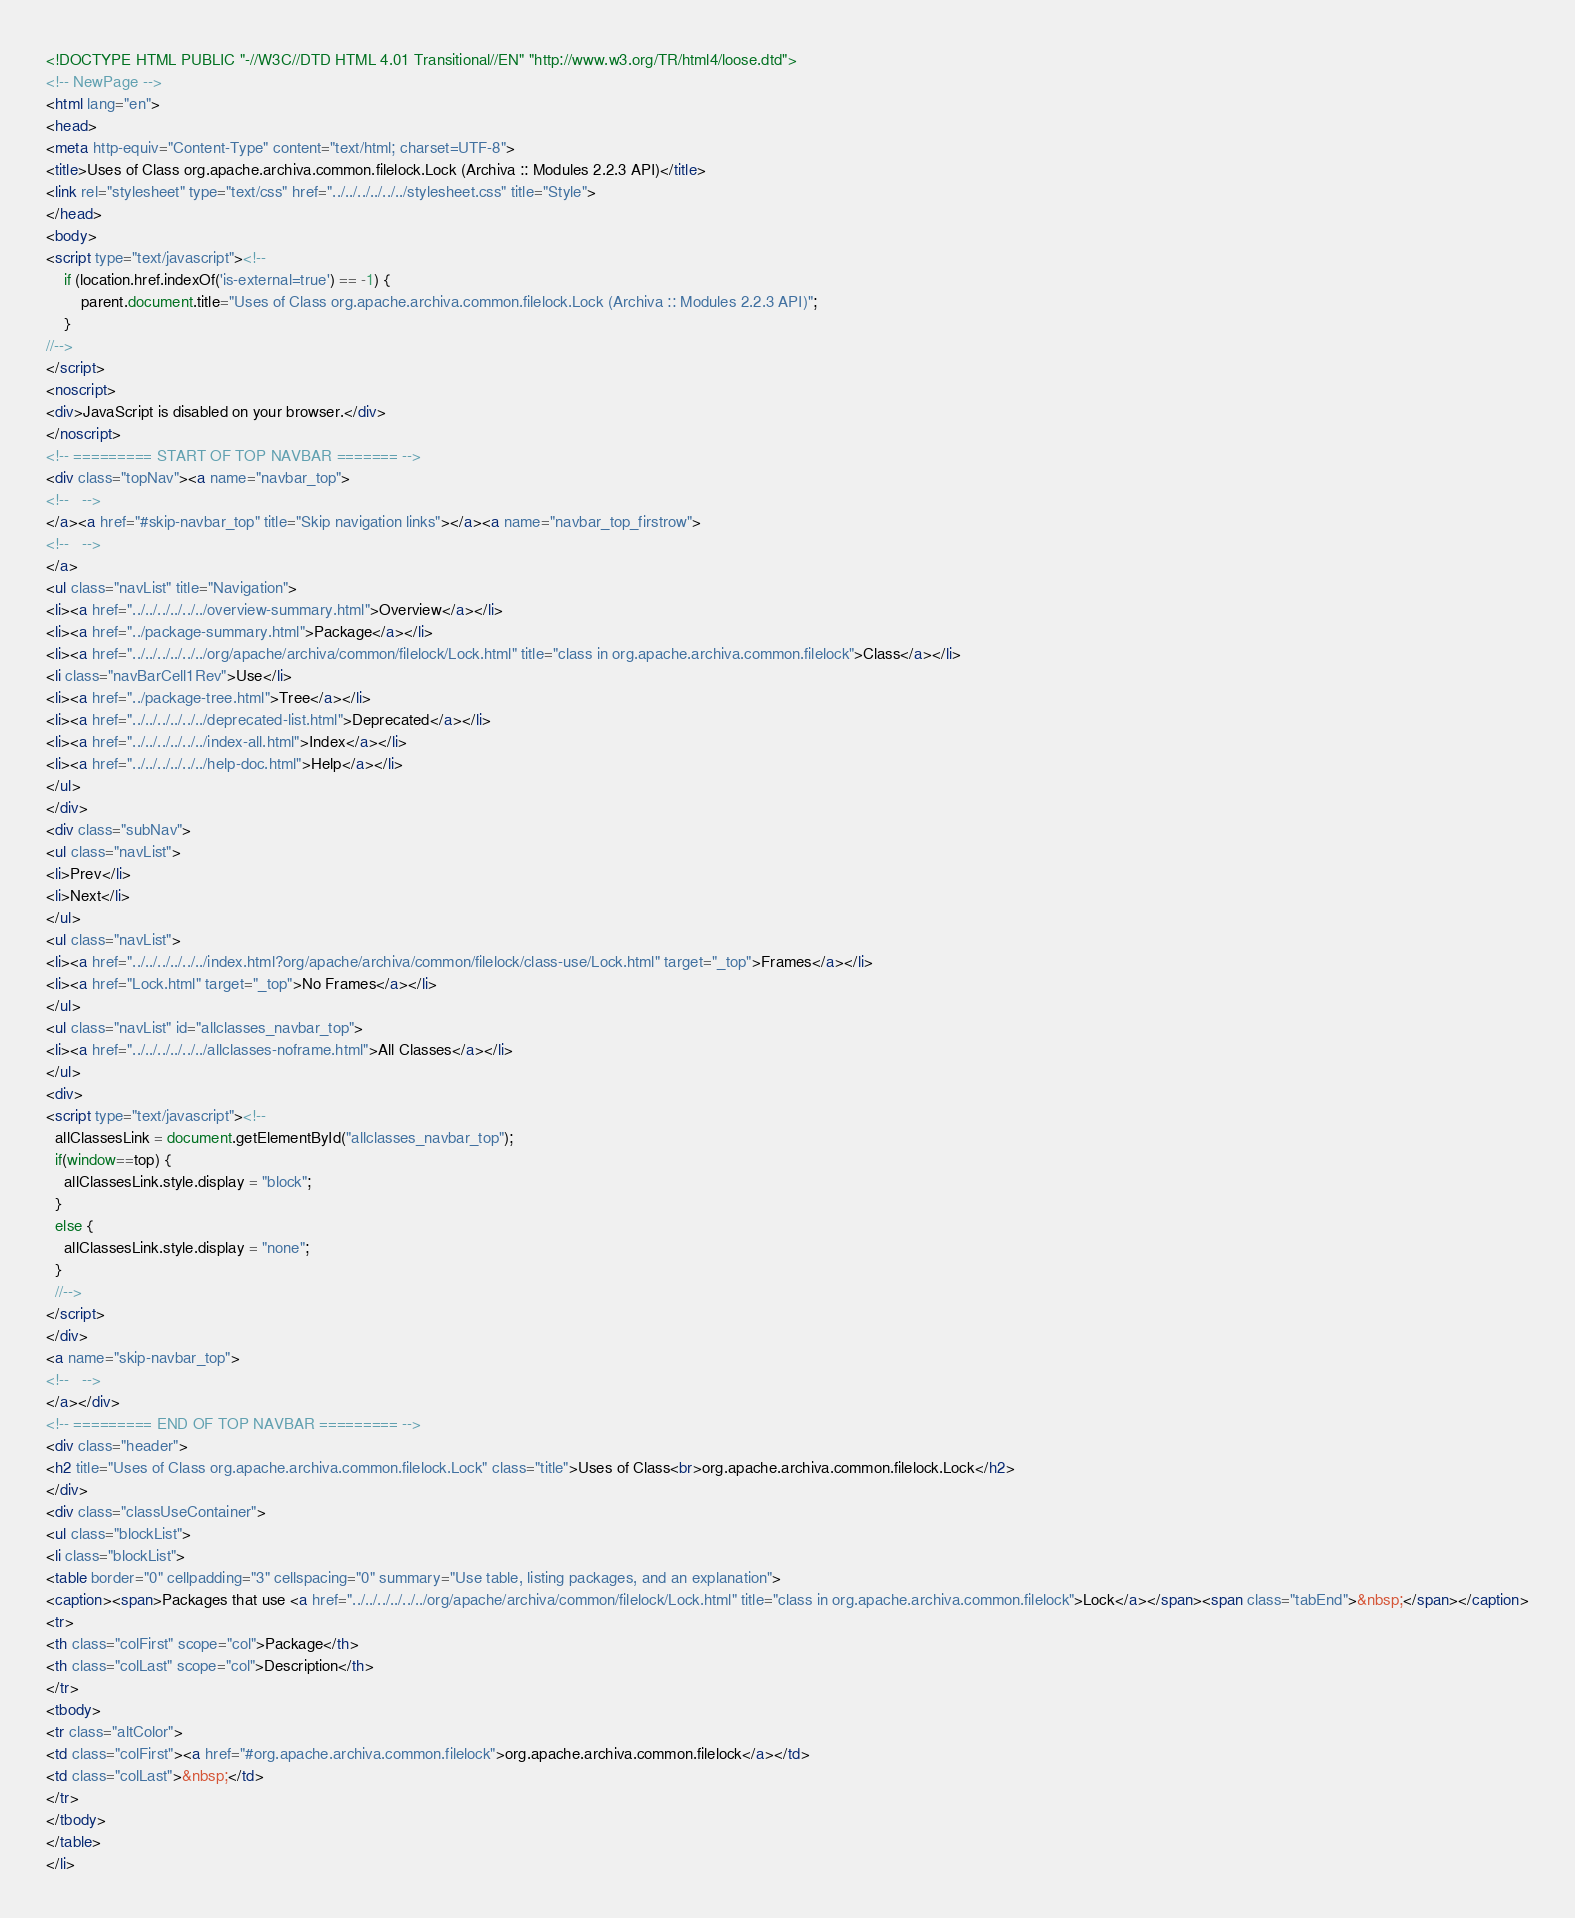<code> <loc_0><loc_0><loc_500><loc_500><_HTML_><!DOCTYPE HTML PUBLIC "-//W3C//DTD HTML 4.01 Transitional//EN" "http://www.w3.org/TR/html4/loose.dtd">
<!-- NewPage -->
<html lang="en">
<head>
<meta http-equiv="Content-Type" content="text/html; charset=UTF-8">
<title>Uses of Class org.apache.archiva.common.filelock.Lock (Archiva :: Modules 2.2.3 API)</title>
<link rel="stylesheet" type="text/css" href="../../../../../../stylesheet.css" title="Style">
</head>
<body>
<script type="text/javascript"><!--
    if (location.href.indexOf('is-external=true') == -1) {
        parent.document.title="Uses of Class org.apache.archiva.common.filelock.Lock (Archiva :: Modules 2.2.3 API)";
    }
//-->
</script>
<noscript>
<div>JavaScript is disabled on your browser.</div>
</noscript>
<!-- ========= START OF TOP NAVBAR ======= -->
<div class="topNav"><a name="navbar_top">
<!--   -->
</a><a href="#skip-navbar_top" title="Skip navigation links"></a><a name="navbar_top_firstrow">
<!--   -->
</a>
<ul class="navList" title="Navigation">
<li><a href="../../../../../../overview-summary.html">Overview</a></li>
<li><a href="../package-summary.html">Package</a></li>
<li><a href="../../../../../../org/apache/archiva/common/filelock/Lock.html" title="class in org.apache.archiva.common.filelock">Class</a></li>
<li class="navBarCell1Rev">Use</li>
<li><a href="../package-tree.html">Tree</a></li>
<li><a href="../../../../../../deprecated-list.html">Deprecated</a></li>
<li><a href="../../../../../../index-all.html">Index</a></li>
<li><a href="../../../../../../help-doc.html">Help</a></li>
</ul>
</div>
<div class="subNav">
<ul class="navList">
<li>Prev</li>
<li>Next</li>
</ul>
<ul class="navList">
<li><a href="../../../../../../index.html?org/apache/archiva/common/filelock/class-use/Lock.html" target="_top">Frames</a></li>
<li><a href="Lock.html" target="_top">No Frames</a></li>
</ul>
<ul class="navList" id="allclasses_navbar_top">
<li><a href="../../../../../../allclasses-noframe.html">All Classes</a></li>
</ul>
<div>
<script type="text/javascript"><!--
  allClassesLink = document.getElementById("allclasses_navbar_top");
  if(window==top) {
    allClassesLink.style.display = "block";
  }
  else {
    allClassesLink.style.display = "none";
  }
  //-->
</script>
</div>
<a name="skip-navbar_top">
<!--   -->
</a></div>
<!-- ========= END OF TOP NAVBAR ========= -->
<div class="header">
<h2 title="Uses of Class org.apache.archiva.common.filelock.Lock" class="title">Uses of Class<br>org.apache.archiva.common.filelock.Lock</h2>
</div>
<div class="classUseContainer">
<ul class="blockList">
<li class="blockList">
<table border="0" cellpadding="3" cellspacing="0" summary="Use table, listing packages, and an explanation">
<caption><span>Packages that use <a href="../../../../../../org/apache/archiva/common/filelock/Lock.html" title="class in org.apache.archiva.common.filelock">Lock</a></span><span class="tabEnd">&nbsp;</span></caption>
<tr>
<th class="colFirst" scope="col">Package</th>
<th class="colLast" scope="col">Description</th>
</tr>
<tbody>
<tr class="altColor">
<td class="colFirst"><a href="#org.apache.archiva.common.filelock">org.apache.archiva.common.filelock</a></td>
<td class="colLast">&nbsp;</td>
</tr>
</tbody>
</table>
</li></code> 